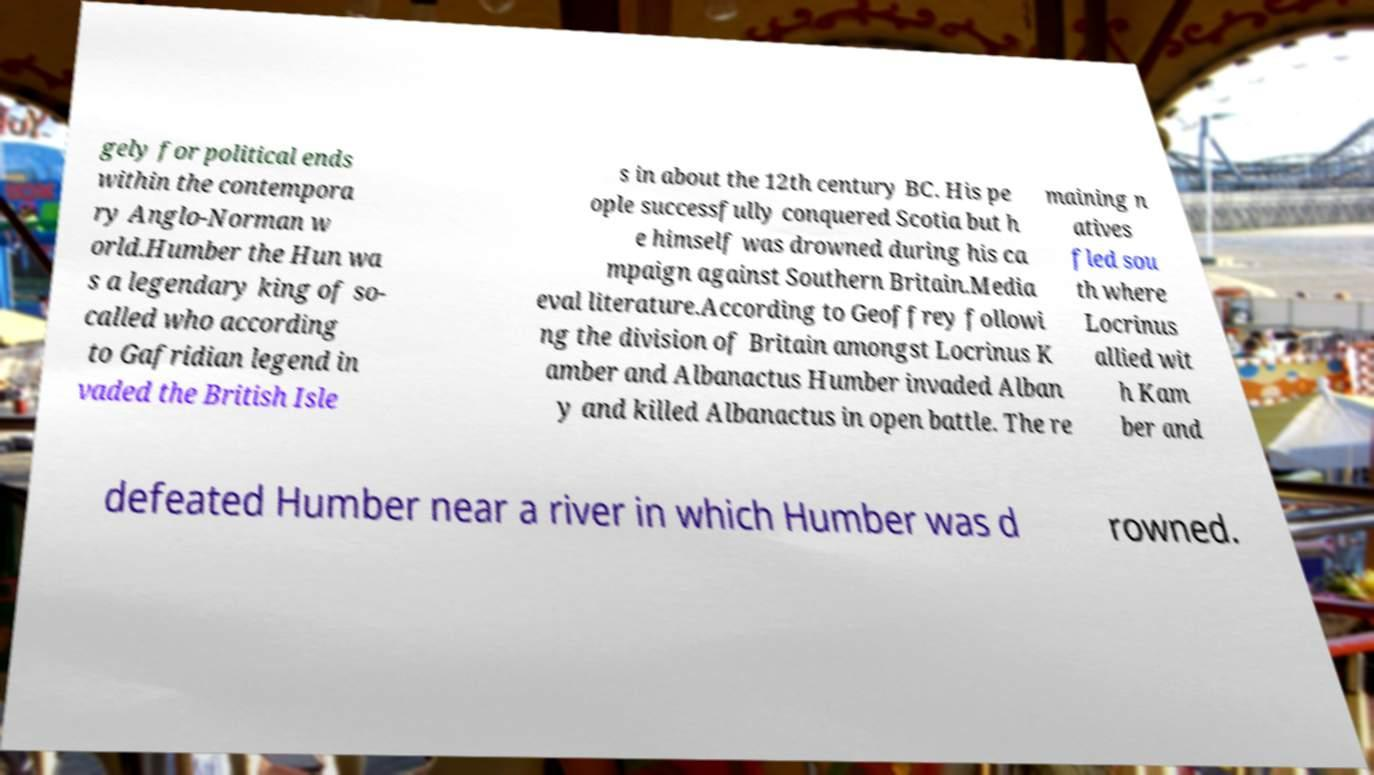There's text embedded in this image that I need extracted. Can you transcribe it verbatim? gely for political ends within the contempora ry Anglo-Norman w orld.Humber the Hun wa s a legendary king of so- called who according to Gafridian legend in vaded the British Isle s in about the 12th century BC. His pe ople successfully conquered Scotia but h e himself was drowned during his ca mpaign against Southern Britain.Media eval literature.According to Geoffrey followi ng the division of Britain amongst Locrinus K amber and Albanactus Humber invaded Alban y and killed Albanactus in open battle. The re maining n atives fled sou th where Locrinus allied wit h Kam ber and defeated Humber near a river in which Humber was d rowned. 